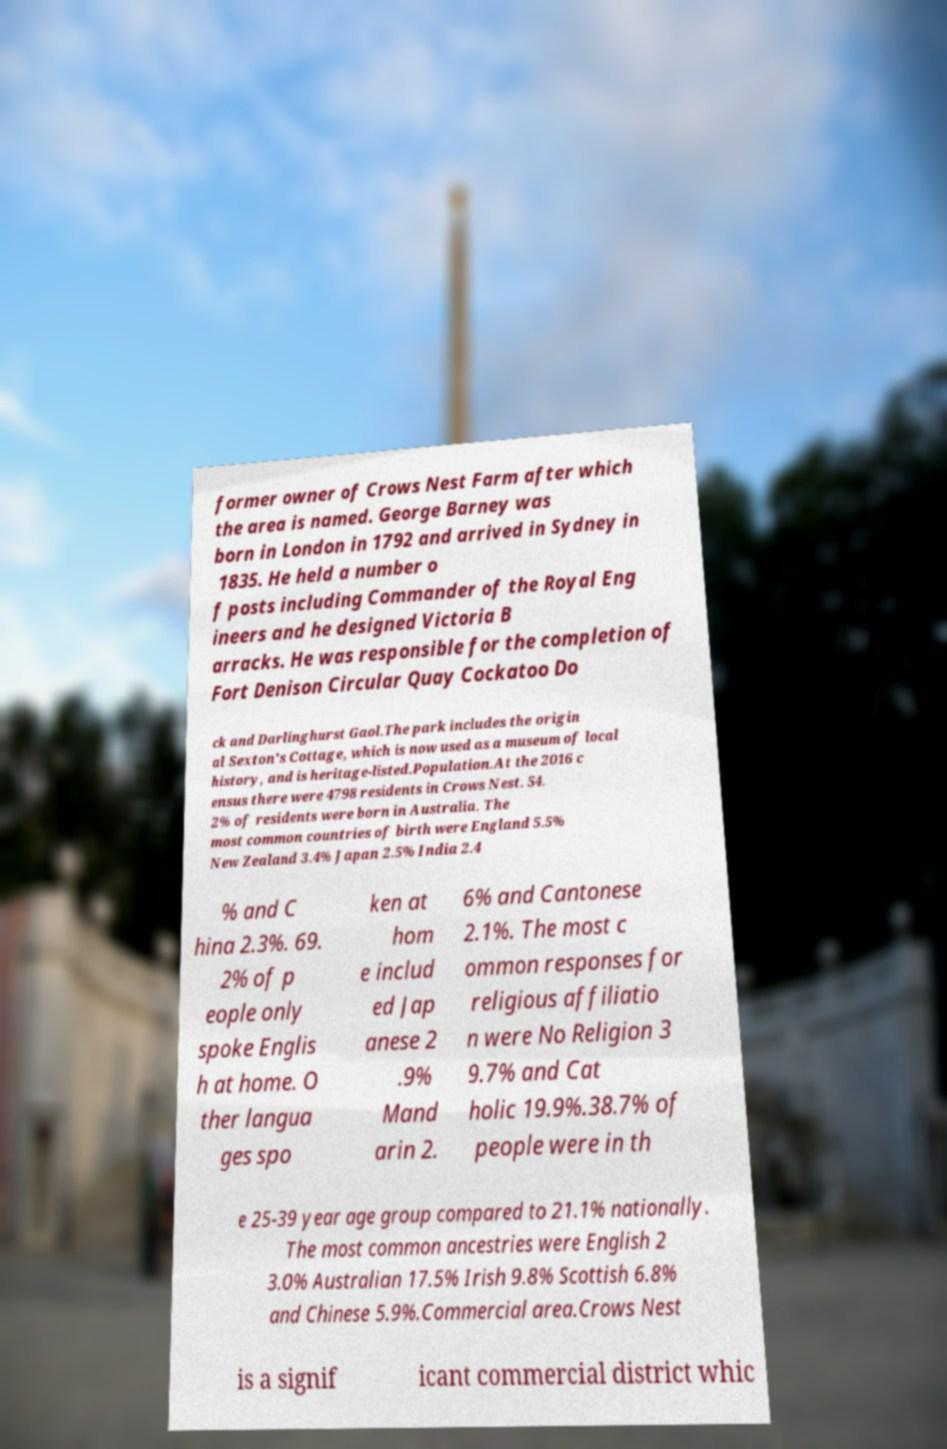Please identify and transcribe the text found in this image. former owner of Crows Nest Farm after which the area is named. George Barney was born in London in 1792 and arrived in Sydney in 1835. He held a number o f posts including Commander of the Royal Eng ineers and he designed Victoria B arracks. He was responsible for the completion of Fort Denison Circular Quay Cockatoo Do ck and Darlinghurst Gaol.The park includes the origin al Sexton's Cottage, which is now used as a museum of local history, and is heritage-listed.Population.At the 2016 c ensus there were 4798 residents in Crows Nest. 54. 2% of residents were born in Australia. The most common countries of birth were England 5.5% New Zealand 3.4% Japan 2.5% India 2.4 % and C hina 2.3%. 69. 2% of p eople only spoke Englis h at home. O ther langua ges spo ken at hom e includ ed Jap anese 2 .9% Mand arin 2. 6% and Cantonese 2.1%. The most c ommon responses for religious affiliatio n were No Religion 3 9.7% and Cat holic 19.9%.38.7% of people were in th e 25-39 year age group compared to 21.1% nationally. The most common ancestries were English 2 3.0% Australian 17.5% Irish 9.8% Scottish 6.8% and Chinese 5.9%.Commercial area.Crows Nest is a signif icant commercial district whic 